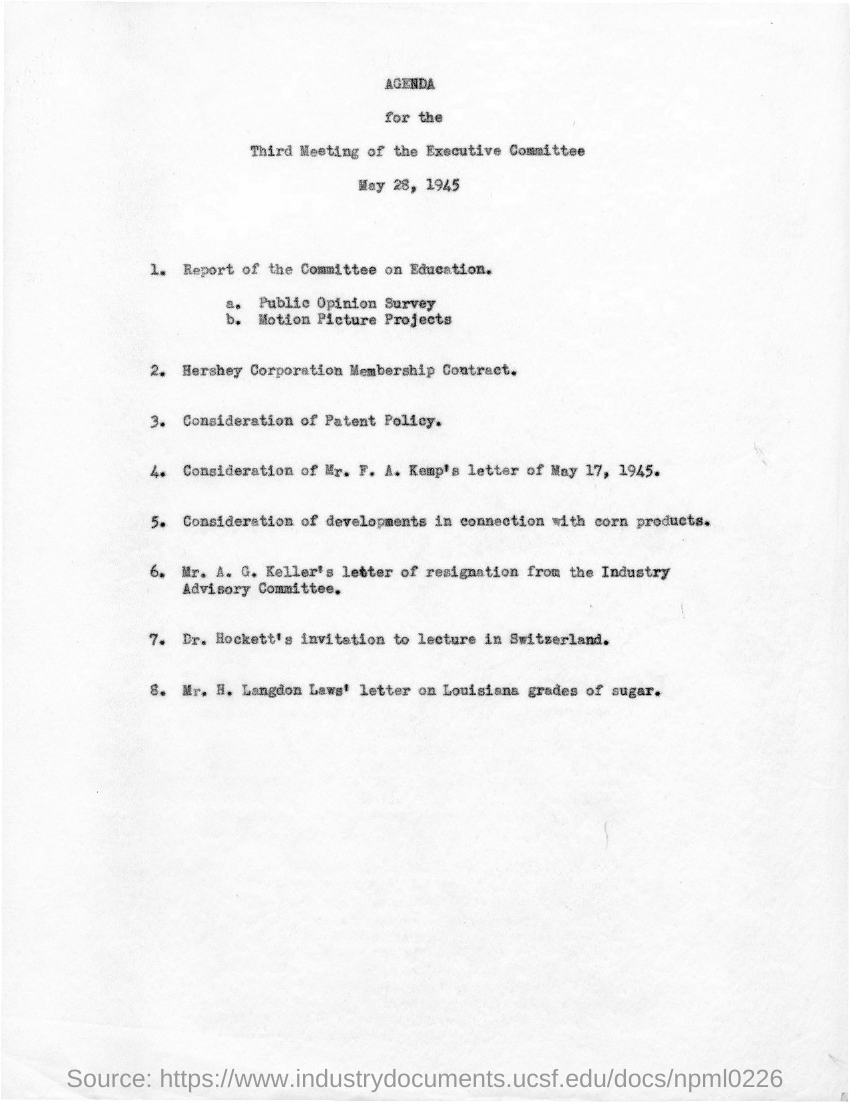What is the title of the document?
Offer a very short reply. AGENDA for the Third Meeting of the Executive Committee May 28, 1945. 